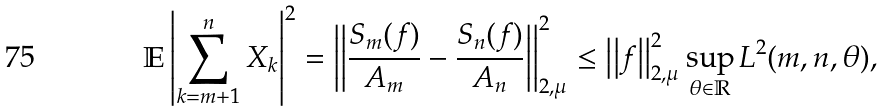<formula> <loc_0><loc_0><loc_500><loc_500>\mathbb { E } \left | \sum _ { k = m + 1 } ^ { n } X _ { k } \right | ^ { 2 } & = \left | \left | \frac { S _ { m } ( f ) } { A _ { m } } - \frac { S _ { n } ( f ) } { A _ { n } } \right | \right | _ { 2 , \mu } ^ { 2 } \leq \left | \left | f \right | \right | _ { 2 , \mu } ^ { 2 } \sup _ { \theta \in \mathbb { R } } L ^ { 2 } ( m , n , \theta ) ,</formula> 